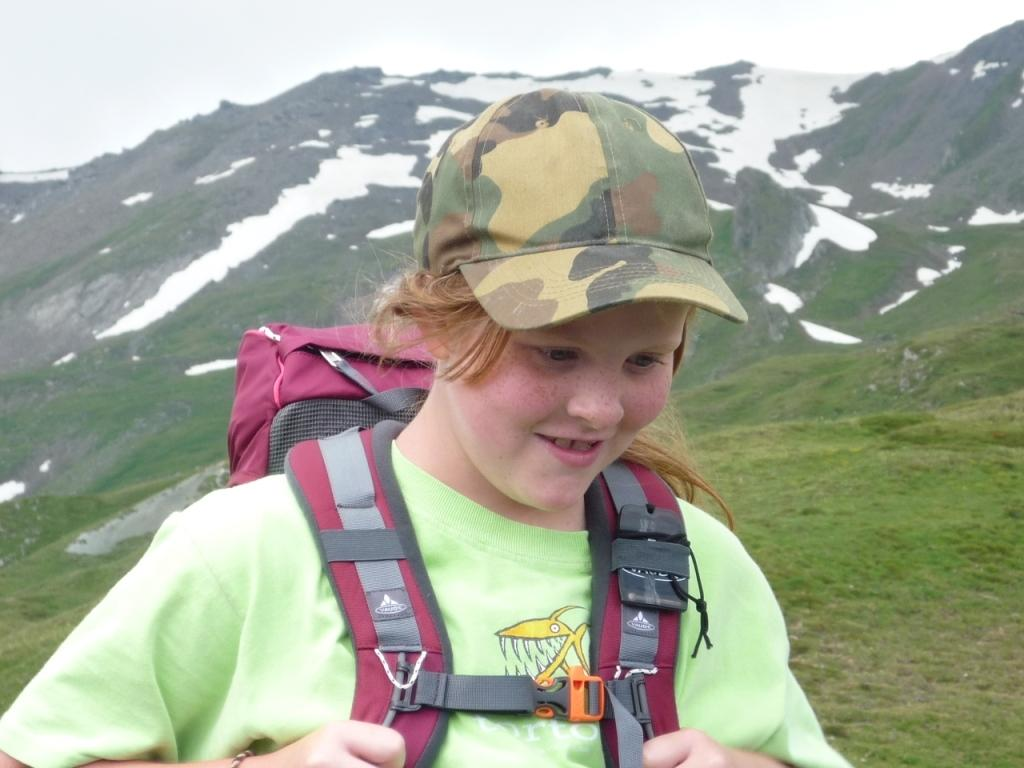Who or what is the main subject in the image? There is a person in the image. What is the person carrying? The person is carrying a backpack. What can be seen in the background of the image? Hills, grass, and the sky are visible in the background of the image. What is the income of the minister in the image? There is no minister present in the image, and therefore no information about their income can be provided. 